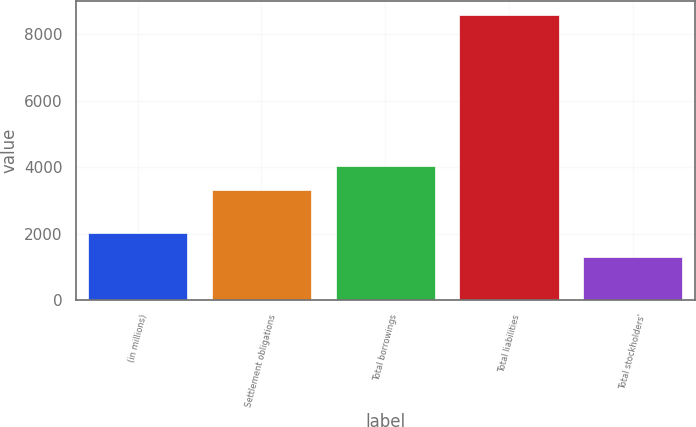Convert chart to OTSL. <chart><loc_0><loc_0><loc_500><loc_500><bar_chart><fcel>(in millions)<fcel>Settlement obligations<fcel>Total borrowings<fcel>Total liabilities<fcel>Total stockholders'<nl><fcel>2028.07<fcel>3313.7<fcel>4041.37<fcel>8577.1<fcel>1300.4<nl></chart> 